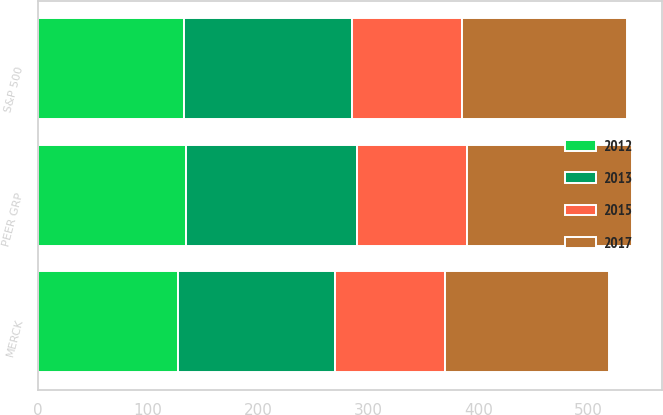<chart> <loc_0><loc_0><loc_500><loc_500><stacked_bar_chart><ecel><fcel>MERCK<fcel>PEER GRP<fcel>S&P 500<nl><fcel>2015<fcel>100<fcel>100<fcel>100<nl><fcel>2012<fcel>126.9<fcel>134.6<fcel>132.4<nl><fcel>2017<fcel>148.7<fcel>150.2<fcel>150.5<nl><fcel>2013<fcel>142.7<fcel>154.7<fcel>152.5<nl></chart> 